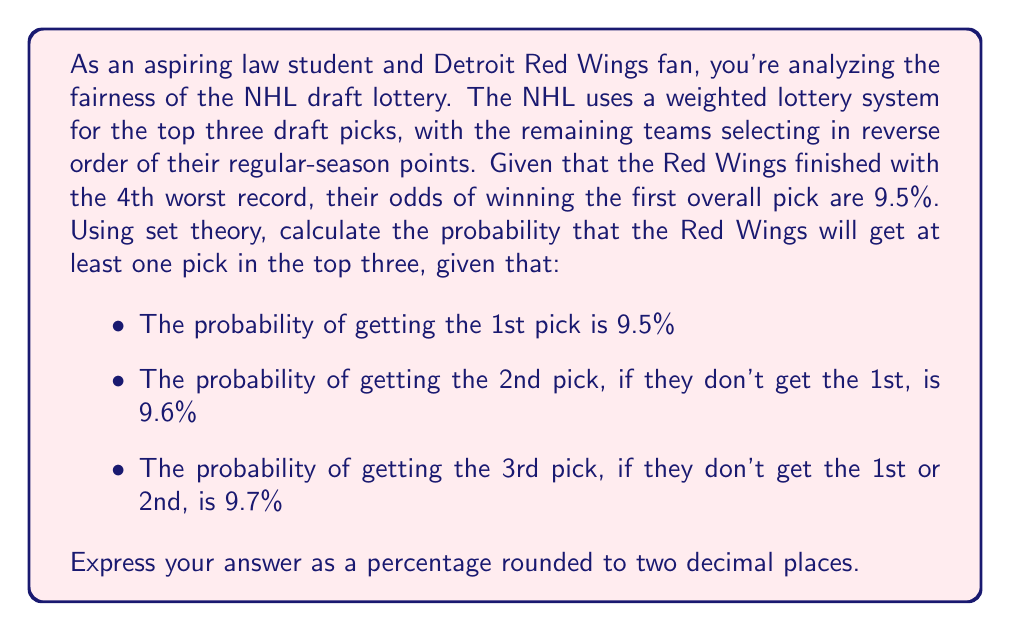What is the answer to this math problem? Let's approach this problem using set theory and the concept of complementary events.

1) First, let's define our events:
   $A$: Red Wings get the 1st pick
   $B$: Red Wings get the 2nd pick
   $C$: Red Wings get the 3rd pick

2) We're looking for $P(A \cup B \cup C)$, the probability of getting at least one of the top three picks.

3) It's easier to calculate the complement of this event: the probability of not getting any of the top three picks.
   $P(\text{not getting any top 3 pick}) = P(\overline{A} \cap \overline{B} \cap \overline{C})$

4) We can calculate this as follows:
   $P(\overline{A} \cap \overline{B} \cap \overline{C}) = P(\overline{A}) \cdot P(\overline{B}|\overline{A}) \cdot P(\overline{C}|\overline{A}\cap\overline{B})$

5) We know:
   $P(A) = 0.095$, so $P(\overline{A}) = 1 - 0.095 = 0.905$
   $P(B|\overline{A}) = 0.096$, so $P(\overline{B}|\overline{A}) = 1 - 0.096 = 0.904$
   $P(C|\overline{A}\cap\overline{B}) = 0.097$, so $P(\overline{C}|\overline{A}\cap\overline{B}) = 1 - 0.097 = 0.903$

6) Now we can calculate:
   $P(\overline{A} \cap \overline{B} \cap \overline{C}) = 0.905 \cdot 0.904 \cdot 0.903 = 0.7379$

7) Therefore, the probability of getting at least one top three pick is:
   $P(A \cup B \cup C) = 1 - P(\overline{A} \cap \overline{B} \cap \overline{C}) = 1 - 0.7379 = 0.2621$

8) Converting to a percentage and rounding to two decimal places:
   $0.2621 \cdot 100 = 26.21\%$
Answer: 26.21% 